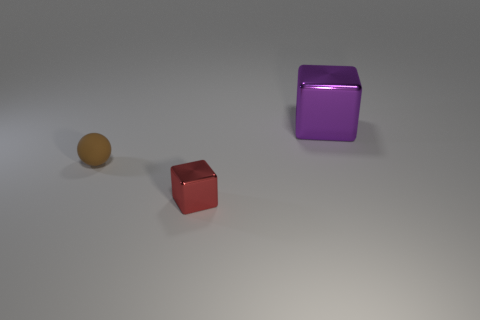Is there anything else that is the same size as the purple cube?
Your answer should be compact. No. What number of red objects are either shiny things or tiny shiny things?
Offer a terse response. 1. Does the block in front of the brown matte sphere have the same size as the thing left of the red cube?
Your answer should be very brief. Yes. How many things are tiny red metallic things or tiny matte things?
Offer a terse response. 2. Are there any small red shiny things that have the same shape as the purple shiny thing?
Offer a terse response. Yes. Is the number of brown metal spheres less than the number of big cubes?
Provide a succinct answer. Yes. Is the big purple metallic thing the same shape as the red thing?
Offer a terse response. Yes. How many things are tiny brown metal cylinders or things behind the matte sphere?
Your answer should be compact. 1. What number of large blue metallic spheres are there?
Make the answer very short. 0. Is there a red metallic thing that has the same size as the brown sphere?
Ensure brevity in your answer.  Yes. 